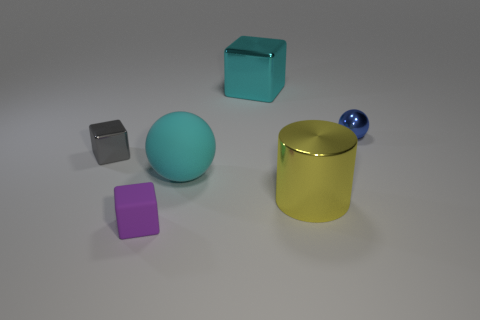Is the color of the cylinder the same as the big matte sphere?
Offer a very short reply. No. What is the material of the large cube that is the same color as the rubber ball?
Offer a very short reply. Metal. What number of big metal things have the same color as the large rubber ball?
Your answer should be very brief. 1. There is a tiny metallic cube; is its color the same as the big object in front of the cyan matte sphere?
Ensure brevity in your answer.  No. What size is the cube that is the same color as the big matte ball?
Your response must be concise. Large. Is there anything else of the same color as the small ball?
Keep it short and to the point. No. There is a tiny metallic object that is on the left side of the big cyan metal cube; does it have the same color as the large rubber thing?
Your response must be concise. No. Are the tiny purple thing and the blue thing made of the same material?
Ensure brevity in your answer.  No. Is the number of things to the left of the cylinder the same as the number of cyan objects right of the purple matte block?
Provide a short and direct response. No. There is a big cyan thing that is the same shape as the blue thing; what material is it?
Offer a very short reply. Rubber. 